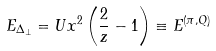Convert formula to latex. <formula><loc_0><loc_0><loc_500><loc_500>E _ { \Delta _ { \perp } } = U x ^ { 2 } \left ( \frac { 2 } { z } - 1 \right ) \equiv E ^ { ( \pi , Q ) }</formula> 